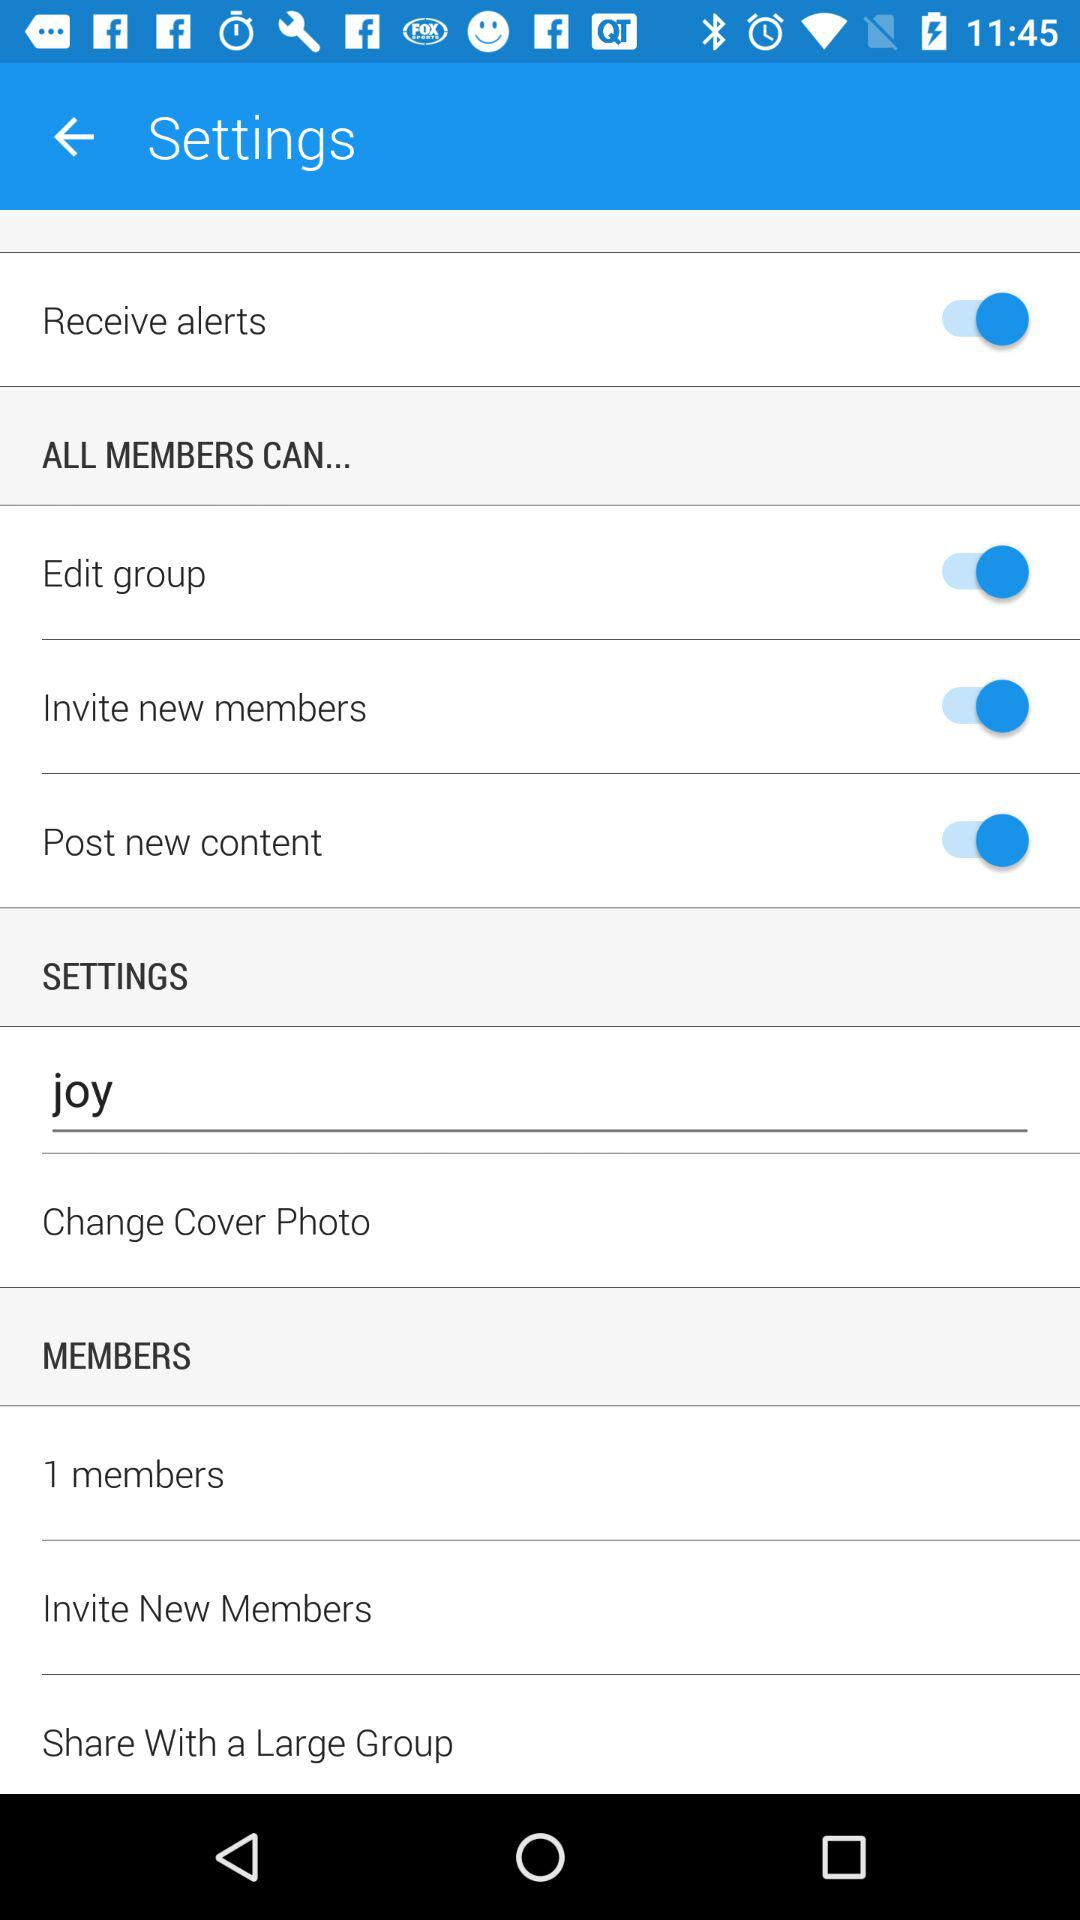How many members are there? There is 1 member. 